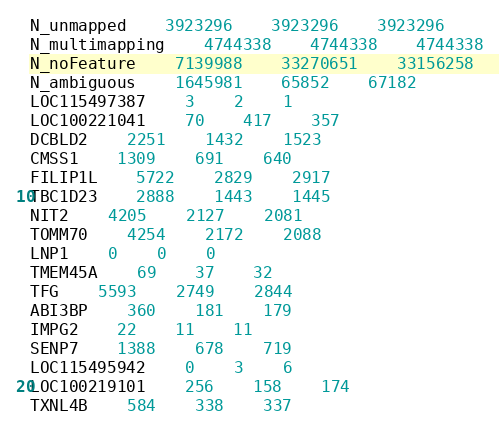Convert code to text. <code><loc_0><loc_0><loc_500><loc_500><_SQL_>N_unmapped	3923296	3923296	3923296
N_multimapping	4744338	4744338	4744338
N_noFeature	7139988	33270651	33156258
N_ambiguous	1645981	65852	67182
LOC115497387	3	2	1
LOC100221041	70	417	357
DCBLD2	2251	1432	1523
CMSS1	1309	691	640
FILIP1L	5722	2829	2917
TBC1D23	2888	1443	1445
NIT2	4205	2127	2081
TOMM70	4254	2172	2088
LNP1	0	0	0
TMEM45A	69	37	32
TFG	5593	2749	2844
ABI3BP	360	181	179
IMPG2	22	11	11
SENP7	1388	678	719
LOC115495942	0	3	6
LOC100219101	256	158	174
TXNL4B	584	338	337</code> 